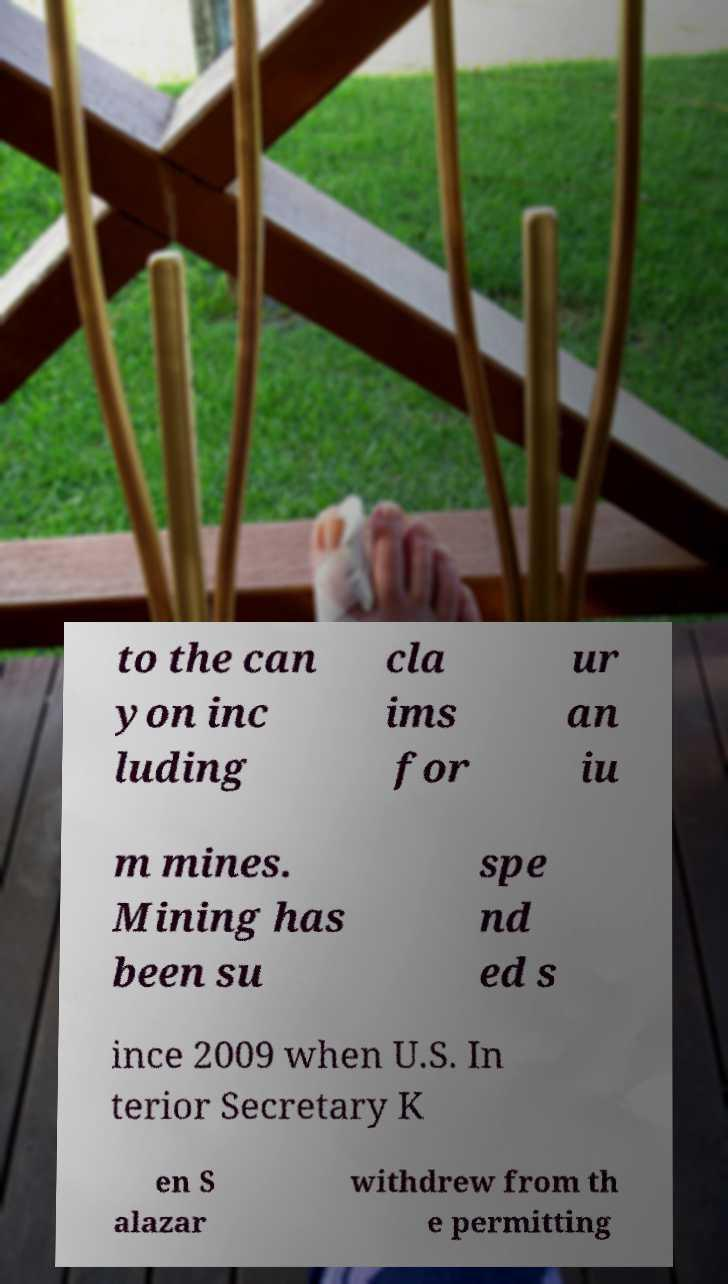Can you accurately transcribe the text from the provided image for me? to the can yon inc luding cla ims for ur an iu m mines. Mining has been su spe nd ed s ince 2009 when U.S. In terior Secretary K en S alazar withdrew from th e permitting 